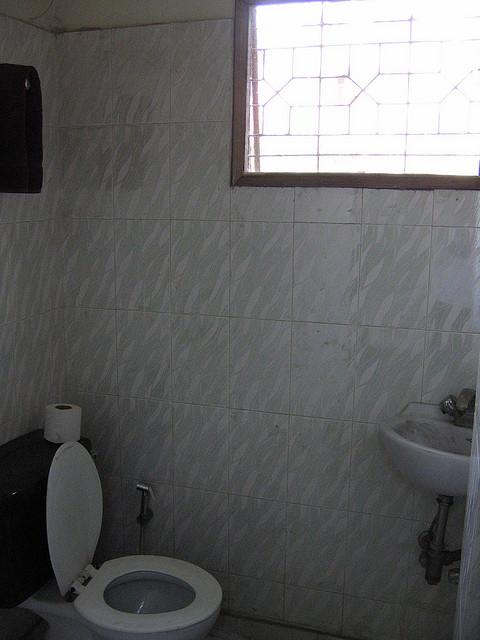Is the toilet seat up?
Concise answer only. Yes. Does the room look clean?
Quick response, please. Yes. Why is the toilet seat open?
Give a very brief answer. Unknown. What color is the toilet?
Short answer required. White. What kind of walls are these?
Concise answer only. Tile. What is on the toilet tank?
Keep it brief. Toilet paper. Is the toilet indoors or out?
Quick response, please. Indoors. Where is the sink?
Keep it brief. Right. How many toilets are visible?
Keep it brief. 1. Does the toilet work properly?
Concise answer only. Yes. Is the a private bathroom?
Give a very brief answer. Yes. What item is the rightmost side of the picture?
Write a very short answer. Sink. How many rectangular tiles are in the picture?
Short answer required. 25. How many panes are in the window?
Short answer required. Many. Is the lid up?
Write a very short answer. Yes. What are the walls made of?
Keep it brief. Tile. Is the toilet lid up or down?
Be succinct. Up. How many full tiles do you see?
Keep it brief. 32. How many paper items are there?
Give a very brief answer. 1. Is this toilet functional?
Concise answer only. Yes. Is the toilet paper roll almost empty?
Answer briefly. No. Is this facility clean or dirty?
Short answer required. Clean. Is this where the toilet actually sat?
Give a very brief answer. Yes. Is this a black and white photo?
Keep it brief. No. Is it daytime outside?
Quick response, please. Yes. Is the sink clean?
Be succinct. No. Where might the tissue be?
Concise answer only. Above toilet. Can you  spot mountains?
Answer briefly. No. 